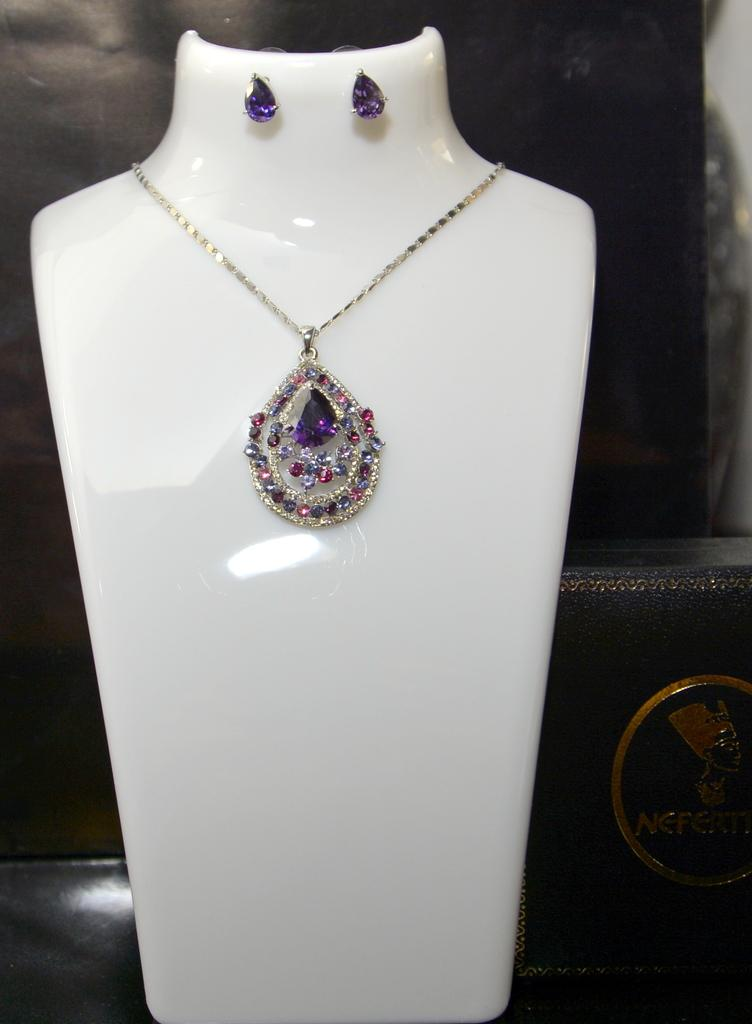What is the main object in the image? The main object in the image is a chain with a locket. What other items are present in the image? There are ear pieces in the image. How are the chain, locket, and ear pieces arranged in the image? The chain, locket, and ear pieces are placed over a surface or area. How many dogs can be seen playing with the gate in the image? There are no dogs or gates present in the image; it features a chain, locket, and ear pieces placed over a surface or area. 